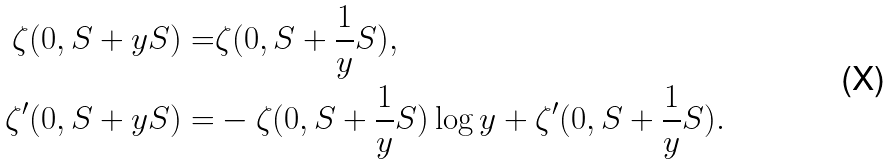Convert formula to latex. <formula><loc_0><loc_0><loc_500><loc_500>\zeta ( 0 , S + y S ) = & \zeta ( 0 , S + \frac { 1 } { y } S ) , \\ \zeta ^ { \prime } ( 0 , S + y S ) = & - \zeta ( 0 , S + \frac { 1 } { y } S ) \log y + \zeta ^ { \prime } ( 0 , S + \frac { 1 } { y } S ) .</formula> 